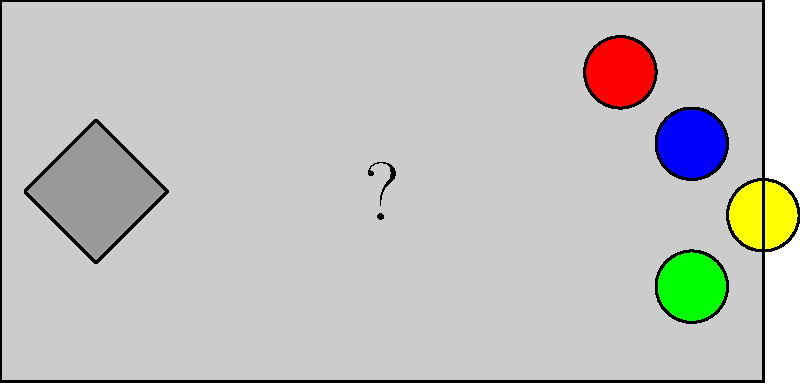Identify the classic gaming console this controller most closely resembles. Which iconic 8-bit system brought this design to millions of homes? 1. Observe the overall shape of the controller: It's rectangular with rounded edges, a common design for early console controllers.

2. Note the directional pad (D-pad) on the left side: This cross-shaped input method was revolutionary for its time.

3. Examine the button layout on the right side: There are four buttons arranged in a diamond pattern.

4. Consider the color scheme: While the diagram is mostly grayscale, the buttons are colored red, blue, yellow, and green, which is reminiscent of the European/Japanese Super Famicom controller.

5. However, the key detail is the number of buttons: There are only two main action buttons (the top two), which is characteristic of the original Nintendo Entertainment System (NES) controller.

6. The NES controller had this exact layout: A rectangle shape, left-side D-pad, two round buttons on the right, and "Start" and "Select" buttons in the center (not clearly visible in this simplified diagram).

7. The NES, released in 1983 in Japan (as Famicom) and 1985 in North America, was the first home console to feature this controller design, which became iconic and influential for future gaming controllers.

Given these observations, especially the two-button layout, this controller most closely resembles the Nintendo Entertainment System (NES) controller.
Answer: Nintendo Entertainment System (NES) 